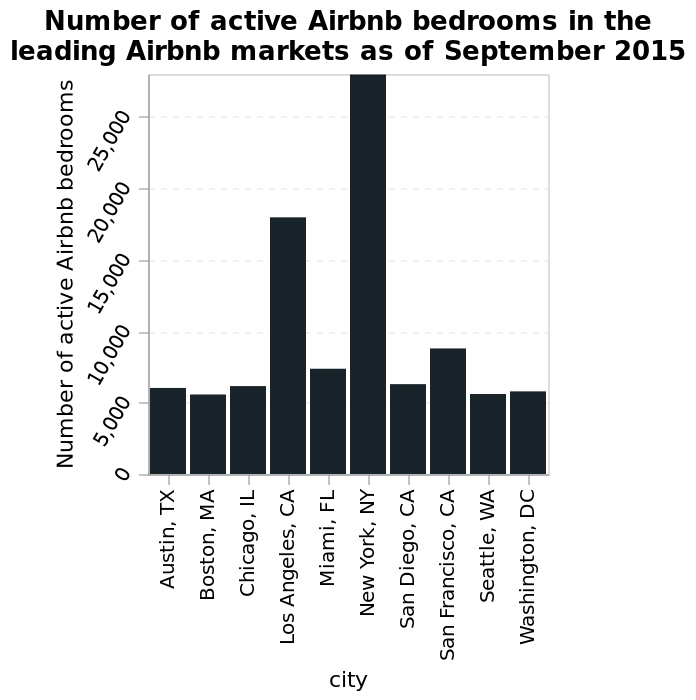<image>
What does the y-axis of the bar graph represent?  The y-axis represents the number of active Airbnb bedrooms with a linear scale from 0 to 25,000. What does the x-axis of the bar graph represent?  The x-axis represents the cities as a categorical scale, starting from Austin, TX and ending at Washington, DC. 